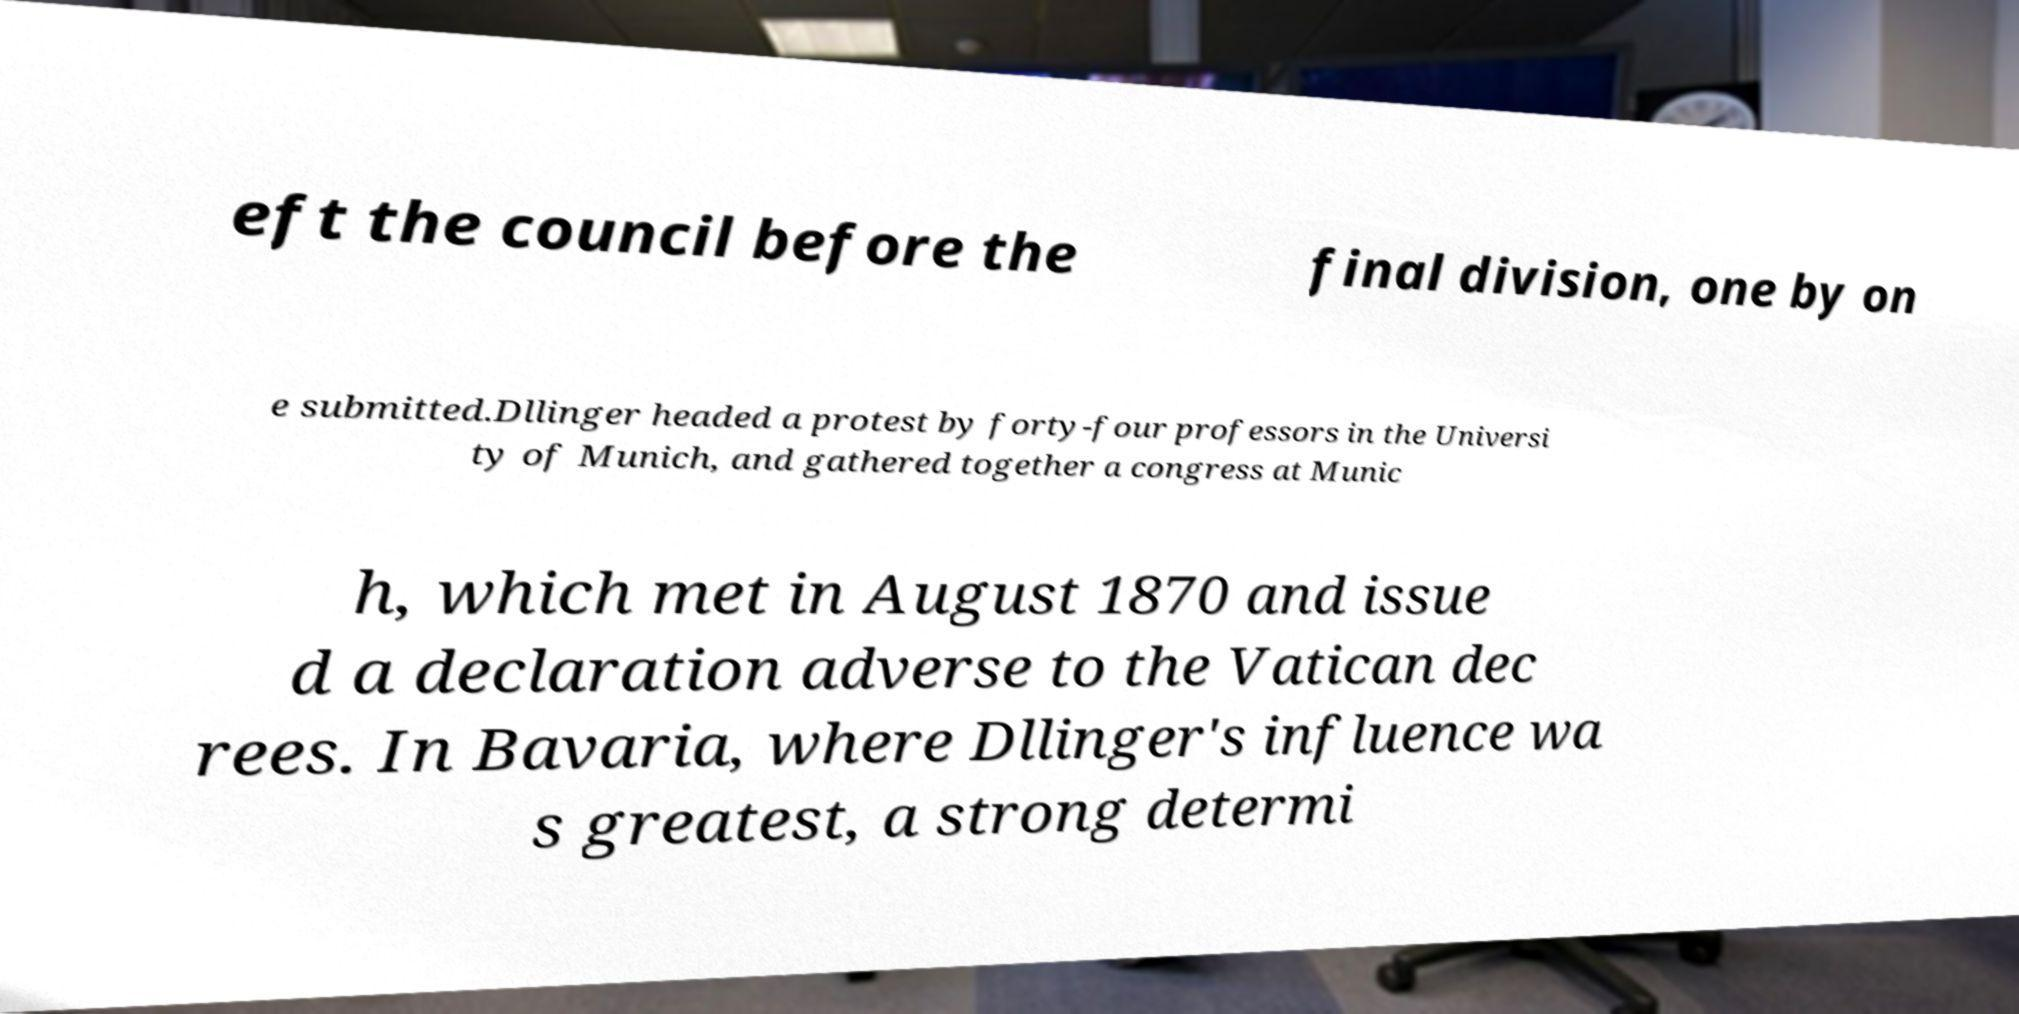There's text embedded in this image that I need extracted. Can you transcribe it verbatim? eft the council before the final division, one by on e submitted.Dllinger headed a protest by forty-four professors in the Universi ty of Munich, and gathered together a congress at Munic h, which met in August 1870 and issue d a declaration adverse to the Vatican dec rees. In Bavaria, where Dllinger's influence wa s greatest, a strong determi 